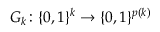Convert formula to latex. <formula><loc_0><loc_0><loc_500><loc_500>G _ { k } \colon \{ 0 , 1 \} ^ { k } \to \{ 0 , 1 \} ^ { p ( k ) }</formula> 